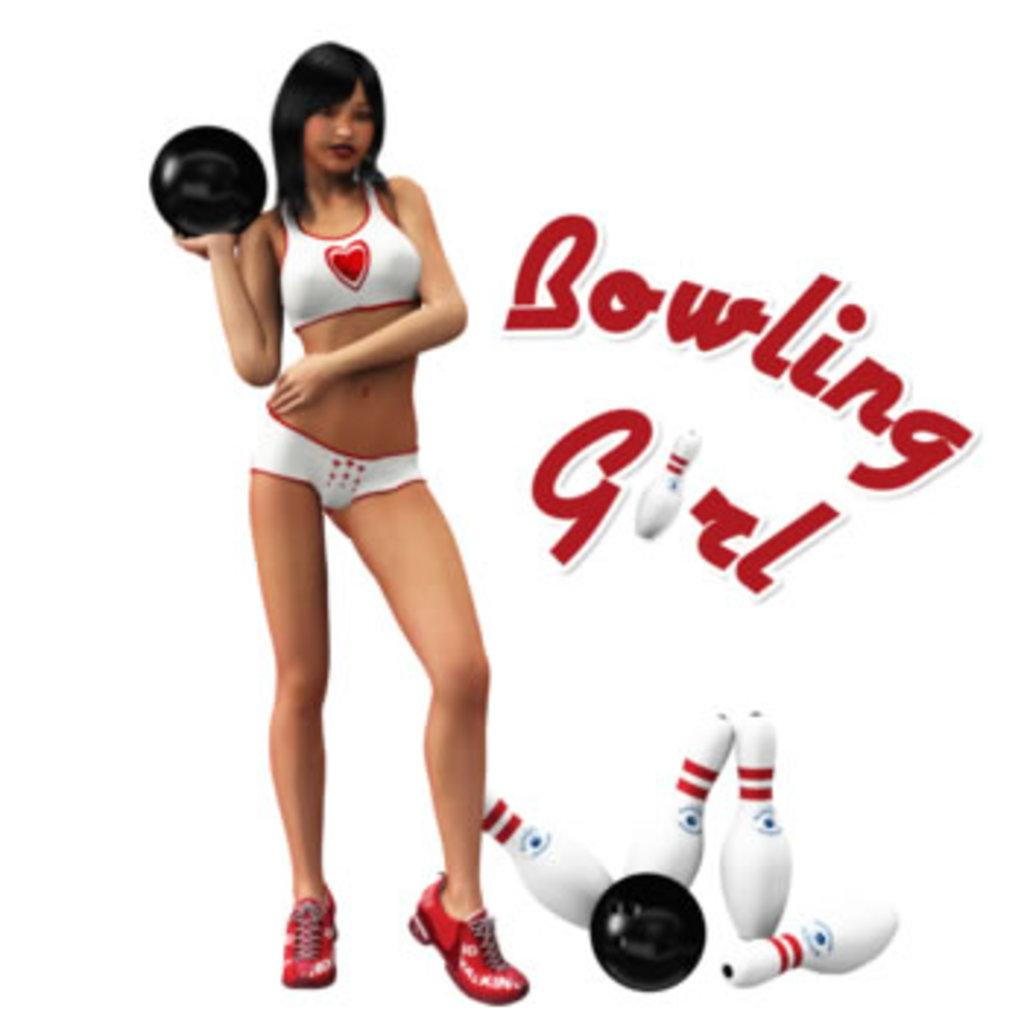<image>
Create a compact narrative representing the image presented. A woman in bowing shoes with the caption Bowling Girl. 